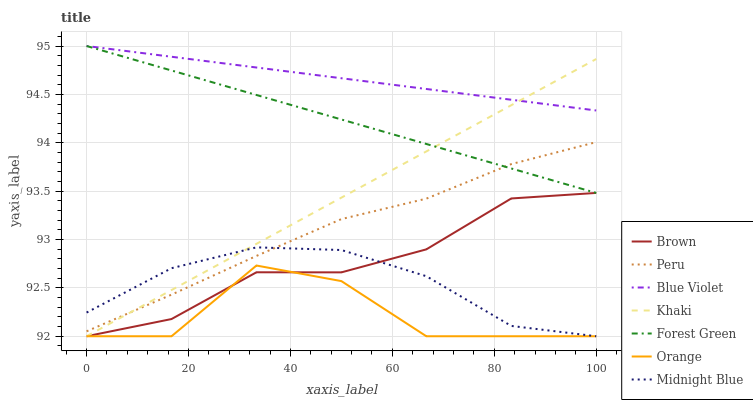Does Orange have the minimum area under the curve?
Answer yes or no. Yes. Does Blue Violet have the maximum area under the curve?
Answer yes or no. Yes. Does Khaki have the minimum area under the curve?
Answer yes or no. No. Does Khaki have the maximum area under the curve?
Answer yes or no. No. Is Forest Green the smoothest?
Answer yes or no. Yes. Is Orange the roughest?
Answer yes or no. Yes. Is Khaki the smoothest?
Answer yes or no. No. Is Khaki the roughest?
Answer yes or no. No. Does Forest Green have the lowest value?
Answer yes or no. No. Does Blue Violet have the highest value?
Answer yes or no. Yes. Does Khaki have the highest value?
Answer yes or no. No. Is Orange less than Blue Violet?
Answer yes or no. Yes. Is Forest Green greater than Midnight Blue?
Answer yes or no. Yes. Does Orange intersect Blue Violet?
Answer yes or no. No. 